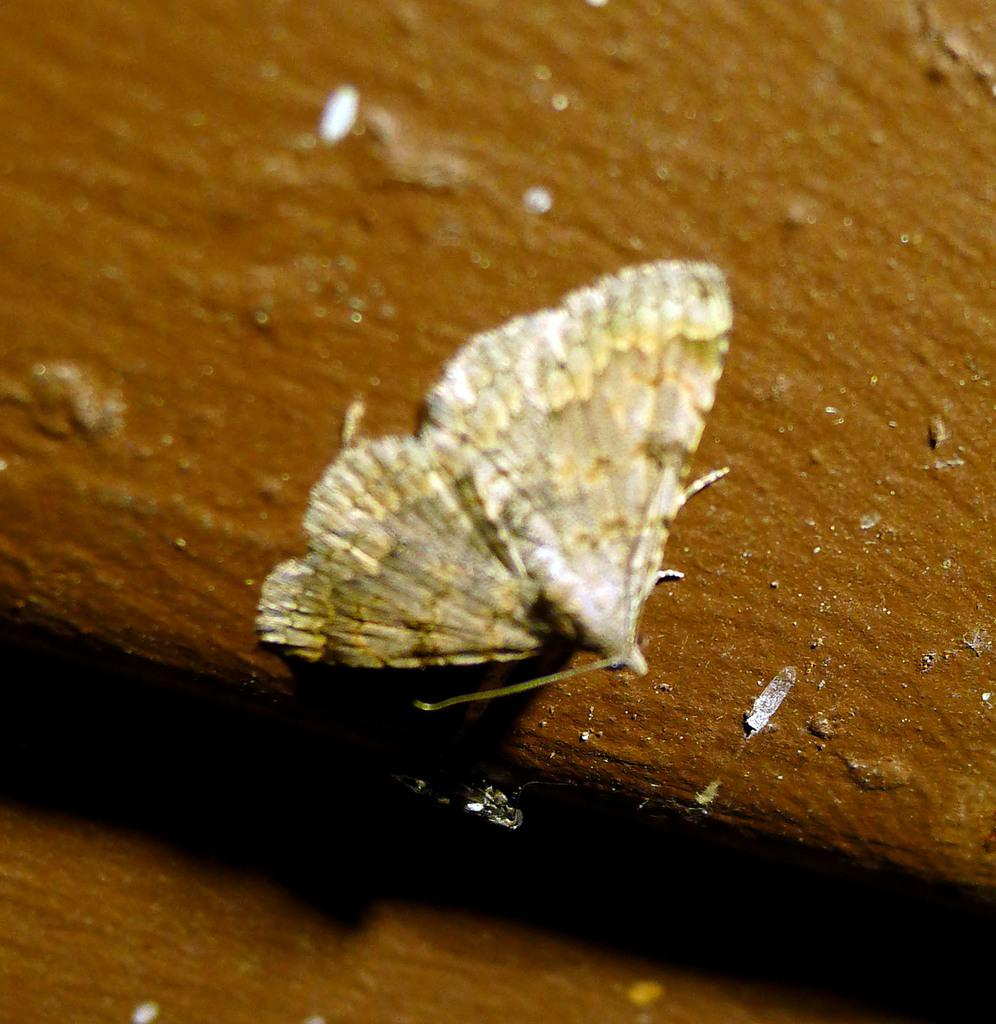What type of insect is in the image? There is a brown color butterfly in the image. Where is the butterfly located in the image? The butterfly is sitting on a tree trunk. What type of volleyball game is being played in the image? There is no volleyball game present in the image; it features a brown color butterfly sitting on a tree trunk. Who is the creator of the butterfly in the image? Butterflies are not created by humans, but rather are a part of nature, so there is no specific creator for the butterfly in the image. 